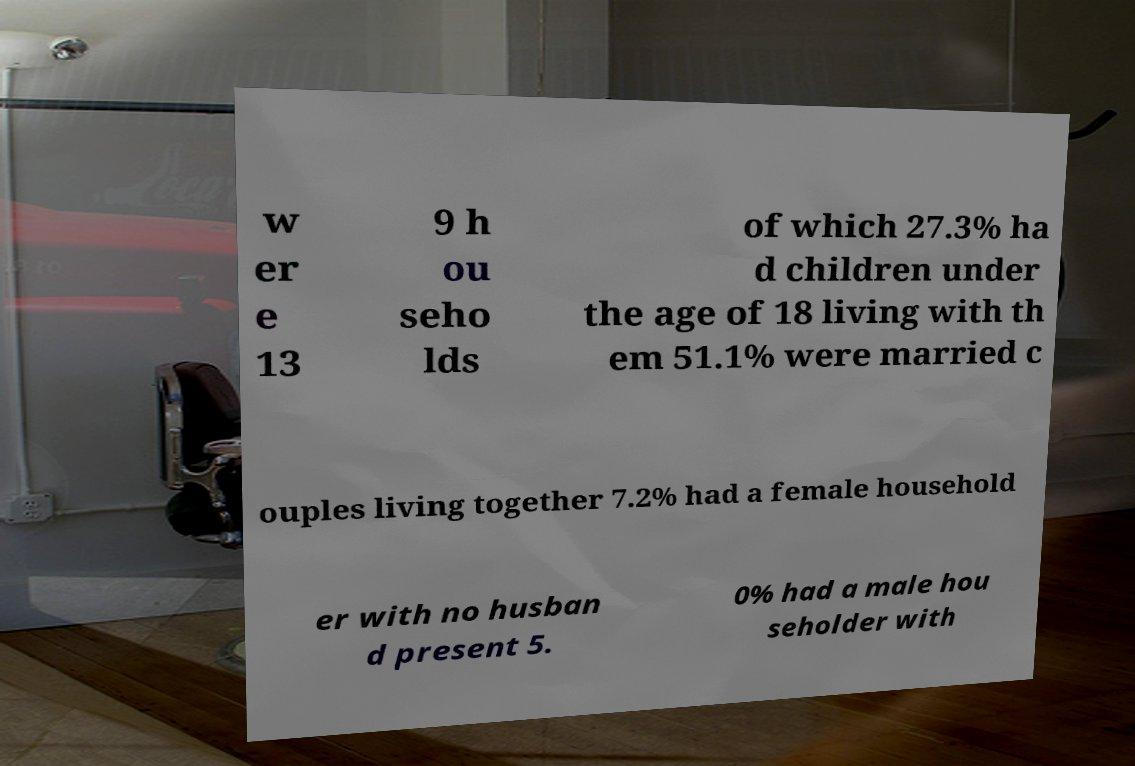Please read and relay the text visible in this image. What does it say? w er e 13 9 h ou seho lds of which 27.3% ha d children under the age of 18 living with th em 51.1% were married c ouples living together 7.2% had a female household er with no husban d present 5. 0% had a male hou seholder with 